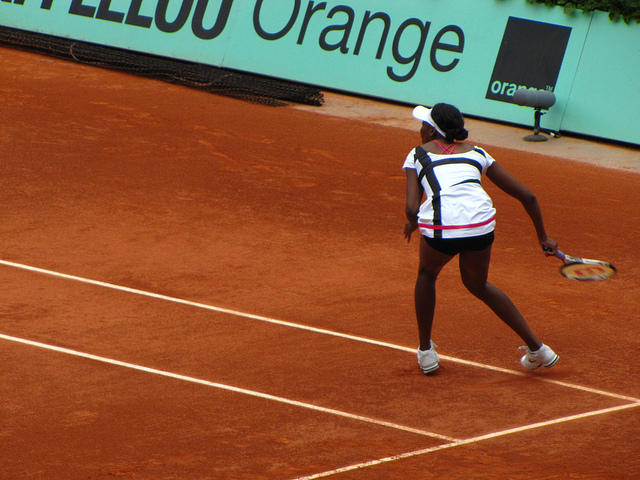<image>Will the player be able to return the ball? It is uncertain if the player will be able to return the ball. Will the player be able to return the ball? I don't know if the player will be able to return the ball. It can be both yes or no. 